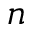Convert formula to latex. <formula><loc_0><loc_0><loc_500><loc_500>n</formula> 